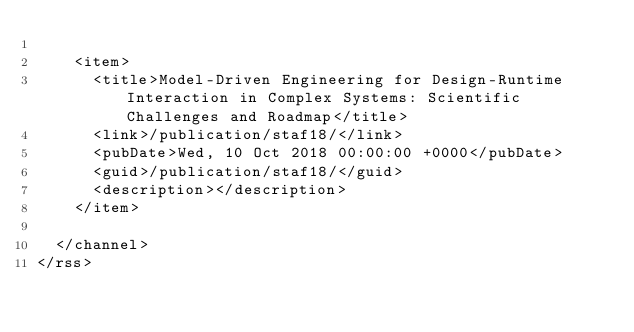<code> <loc_0><loc_0><loc_500><loc_500><_XML_>    
    <item>
      <title>Model-Driven Engineering for Design-Runtime Interaction in Complex Systems: Scientific Challenges and Roadmap</title>
      <link>/publication/staf18/</link>
      <pubDate>Wed, 10 Oct 2018 00:00:00 +0000</pubDate>
      <guid>/publication/staf18/</guid>
      <description></description>
    </item>
    
  </channel>
</rss>
</code> 